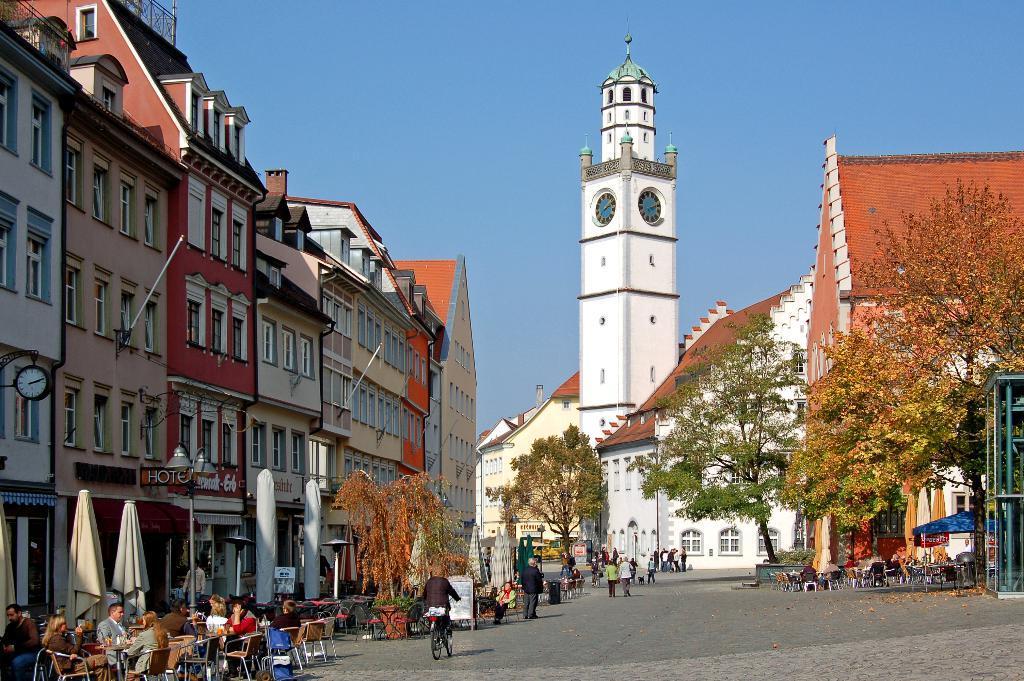In one or two sentences, can you explain what this image depicts? In this image, we can see the road, there is a person riding a bicycle, there are some people sitting on the chairs, we can see some trees, there are some buildings, we can see some windows on the buildings, at the top there is a sky. 